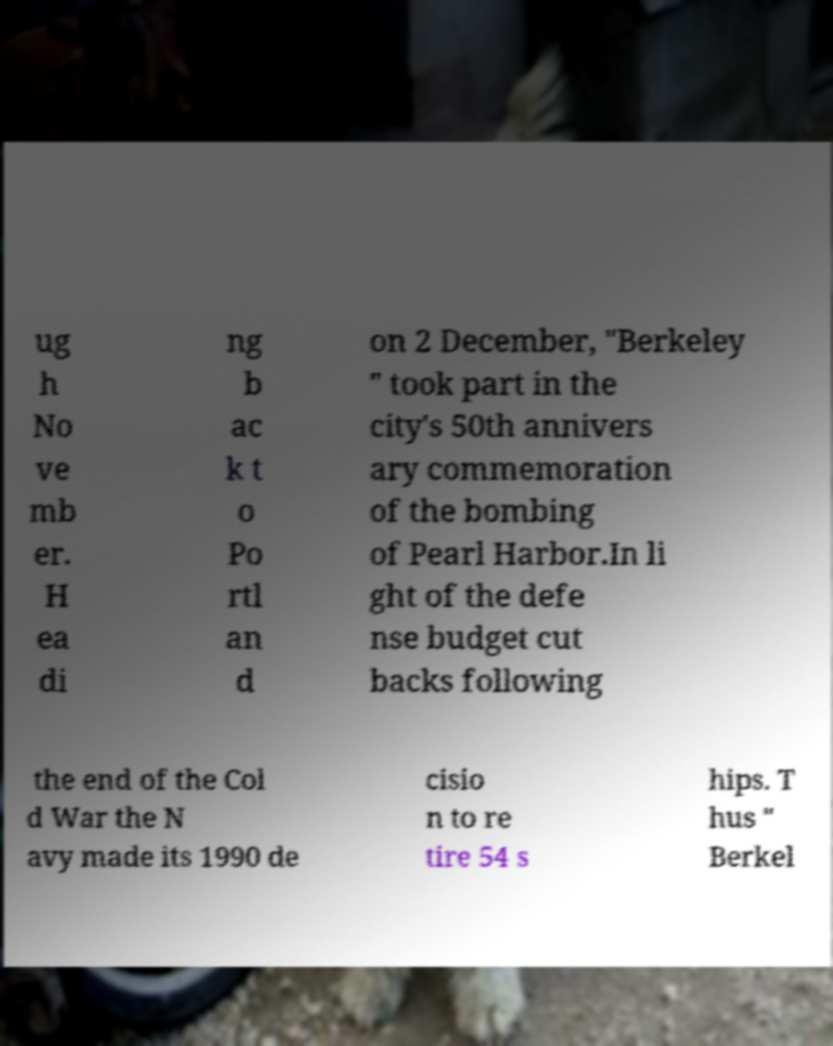Could you assist in decoding the text presented in this image and type it out clearly? ug h No ve mb er. H ea di ng b ac k t o Po rtl an d on 2 December, "Berkeley " took part in the city's 50th annivers ary commemoration of the bombing of Pearl Harbor.In li ght of the defe nse budget cut backs following the end of the Col d War the N avy made its 1990 de cisio n to re tire 54 s hips. T hus " Berkel 